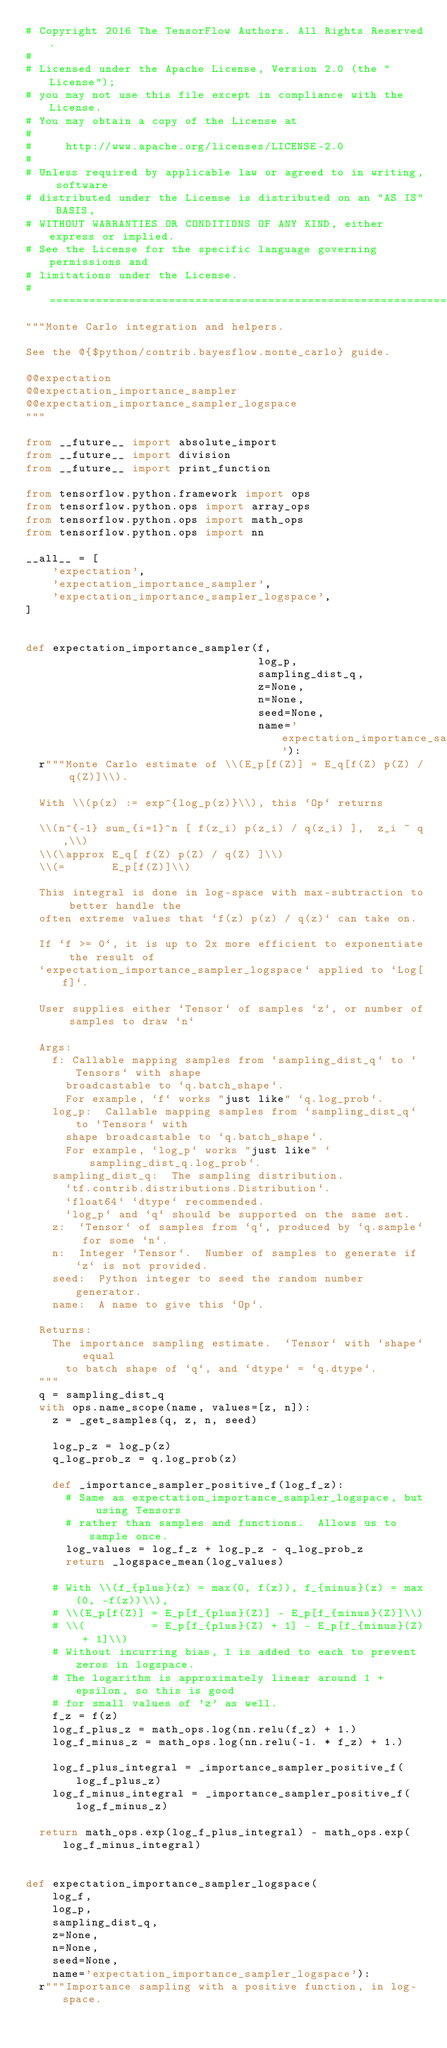<code> <loc_0><loc_0><loc_500><loc_500><_Python_># Copyright 2016 The TensorFlow Authors. All Rights Reserved.
#
# Licensed under the Apache License, Version 2.0 (the "License");
# you may not use this file except in compliance with the License.
# You may obtain a copy of the License at
#
#     http://www.apache.org/licenses/LICENSE-2.0
#
# Unless required by applicable law or agreed to in writing, software
# distributed under the License is distributed on an "AS IS" BASIS,
# WITHOUT WARRANTIES OR CONDITIONS OF ANY KIND, either express or implied.
# See the License for the specific language governing permissions and
# limitations under the License.
# ==============================================================================
"""Monte Carlo integration and helpers.

See the @{$python/contrib.bayesflow.monte_carlo} guide.

@@expectation
@@expectation_importance_sampler
@@expectation_importance_sampler_logspace
"""

from __future__ import absolute_import
from __future__ import division
from __future__ import print_function

from tensorflow.python.framework import ops
from tensorflow.python.ops import array_ops
from tensorflow.python.ops import math_ops
from tensorflow.python.ops import nn

__all__ = [
    'expectation',
    'expectation_importance_sampler',
    'expectation_importance_sampler_logspace',
]


def expectation_importance_sampler(f,
                                   log_p,
                                   sampling_dist_q,
                                   z=None,
                                   n=None,
                                   seed=None,
                                   name='expectation_importance_sampler'):
  r"""Monte Carlo estimate of \\(E_p[f(Z)] = E_q[f(Z) p(Z) / q(Z)]\\).

  With \\(p(z) := exp^{log_p(z)}\\), this `Op` returns

  \\(n^{-1} sum_{i=1}^n [ f(z_i) p(z_i) / q(z_i) ],  z_i ~ q,\\)
  \\(\approx E_q[ f(Z) p(Z) / q(Z) ]\\)
  \\(=       E_p[f(Z)]\\)

  This integral is done in log-space with max-subtraction to better handle the
  often extreme values that `f(z) p(z) / q(z)` can take on.

  If `f >= 0`, it is up to 2x more efficient to exponentiate the result of
  `expectation_importance_sampler_logspace` applied to `Log[f]`.

  User supplies either `Tensor` of samples `z`, or number of samples to draw `n`

  Args:
    f: Callable mapping samples from `sampling_dist_q` to `Tensors` with shape
      broadcastable to `q.batch_shape`.
      For example, `f` works "just like" `q.log_prob`.
    log_p:  Callable mapping samples from `sampling_dist_q` to `Tensors` with
      shape broadcastable to `q.batch_shape`.
      For example, `log_p` works "just like" `sampling_dist_q.log_prob`.
    sampling_dist_q:  The sampling distribution.
      `tf.contrib.distributions.Distribution`.
      `float64` `dtype` recommended.
      `log_p` and `q` should be supported on the same set.
    z:  `Tensor` of samples from `q`, produced by `q.sample` for some `n`.
    n:  Integer `Tensor`.  Number of samples to generate if `z` is not provided.
    seed:  Python integer to seed the random number generator.
    name:  A name to give this `Op`.

  Returns:
    The importance sampling estimate.  `Tensor` with `shape` equal
      to batch shape of `q`, and `dtype` = `q.dtype`.
  """
  q = sampling_dist_q
  with ops.name_scope(name, values=[z, n]):
    z = _get_samples(q, z, n, seed)

    log_p_z = log_p(z)
    q_log_prob_z = q.log_prob(z)

    def _importance_sampler_positive_f(log_f_z):
      # Same as expectation_importance_sampler_logspace, but using Tensors
      # rather than samples and functions.  Allows us to sample once.
      log_values = log_f_z + log_p_z - q_log_prob_z
      return _logspace_mean(log_values)

    # With \\(f_{plus}(z) = max(0, f(z)), f_{minus}(z) = max(0, -f(z))\\),
    # \\(E_p[f(Z)] = E_p[f_{plus}(Z)] - E_p[f_{minus}(Z)]\\)
    # \\(          = E_p[f_{plus}(Z) + 1] - E_p[f_{minus}(Z) + 1]\\)
    # Without incurring bias, 1 is added to each to prevent zeros in logspace.
    # The logarithm is approximately linear around 1 + epsilon, so this is good
    # for small values of 'z' as well.
    f_z = f(z)
    log_f_plus_z = math_ops.log(nn.relu(f_z) + 1.)
    log_f_minus_z = math_ops.log(nn.relu(-1. * f_z) + 1.)

    log_f_plus_integral = _importance_sampler_positive_f(log_f_plus_z)
    log_f_minus_integral = _importance_sampler_positive_f(log_f_minus_z)

  return math_ops.exp(log_f_plus_integral) - math_ops.exp(log_f_minus_integral)


def expectation_importance_sampler_logspace(
    log_f,
    log_p,
    sampling_dist_q,
    z=None,
    n=None,
    seed=None,
    name='expectation_importance_sampler_logspace'):
  r"""Importance sampling with a positive function, in log-space.
</code> 